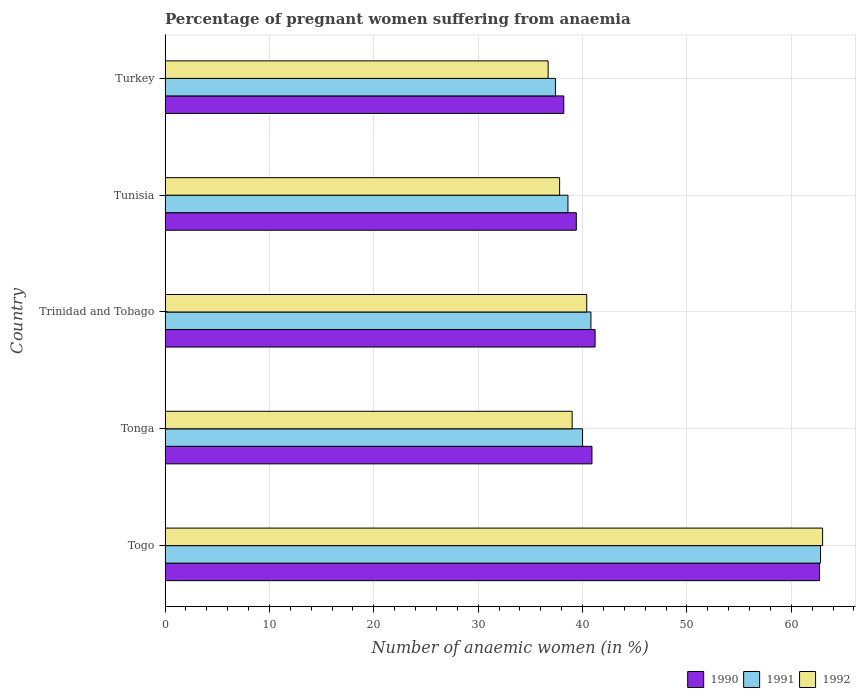How many different coloured bars are there?
Offer a very short reply. 3. Are the number of bars on each tick of the Y-axis equal?
Your answer should be very brief. Yes. What is the label of the 5th group of bars from the top?
Provide a short and direct response. Togo. What is the number of anaemic women in 1990 in Trinidad and Tobago?
Provide a succinct answer. 41.2. Across all countries, what is the maximum number of anaemic women in 1991?
Provide a succinct answer. 62.8. Across all countries, what is the minimum number of anaemic women in 1992?
Your answer should be very brief. 36.7. In which country was the number of anaemic women in 1991 maximum?
Keep it short and to the point. Togo. In which country was the number of anaemic women in 1991 minimum?
Ensure brevity in your answer.  Turkey. What is the total number of anaemic women in 1991 in the graph?
Keep it short and to the point. 219.6. What is the difference between the number of anaemic women in 1990 in Tunisia and that in Turkey?
Your answer should be very brief. 1.2. What is the difference between the number of anaemic women in 1990 in Tunisia and the number of anaemic women in 1991 in Trinidad and Tobago?
Make the answer very short. -1.4. What is the average number of anaemic women in 1991 per country?
Make the answer very short. 43.92. What is the difference between the number of anaemic women in 1990 and number of anaemic women in 1992 in Togo?
Keep it short and to the point. -0.3. In how many countries, is the number of anaemic women in 1992 greater than 62 %?
Keep it short and to the point. 1. What is the ratio of the number of anaemic women in 1991 in Tonga to that in Turkey?
Give a very brief answer. 1.07. What is the difference between the highest and the second highest number of anaemic women in 1992?
Your answer should be compact. 22.6. In how many countries, is the number of anaemic women in 1991 greater than the average number of anaemic women in 1991 taken over all countries?
Offer a very short reply. 1. Is the sum of the number of anaemic women in 1991 in Togo and Turkey greater than the maximum number of anaemic women in 1992 across all countries?
Offer a very short reply. Yes. What does the 1st bar from the top in Turkey represents?
Your response must be concise. 1992. What does the 2nd bar from the bottom in Tonga represents?
Offer a very short reply. 1991. How many bars are there?
Offer a very short reply. 15. What is the difference between two consecutive major ticks on the X-axis?
Give a very brief answer. 10. Are the values on the major ticks of X-axis written in scientific E-notation?
Your answer should be very brief. No. How many legend labels are there?
Your answer should be very brief. 3. How are the legend labels stacked?
Give a very brief answer. Horizontal. What is the title of the graph?
Your answer should be compact. Percentage of pregnant women suffering from anaemia. What is the label or title of the X-axis?
Your response must be concise. Number of anaemic women (in %). What is the Number of anaemic women (in %) of 1990 in Togo?
Offer a terse response. 62.7. What is the Number of anaemic women (in %) in 1991 in Togo?
Keep it short and to the point. 62.8. What is the Number of anaemic women (in %) in 1990 in Tonga?
Offer a terse response. 40.9. What is the Number of anaemic women (in %) of 1991 in Tonga?
Keep it short and to the point. 40. What is the Number of anaemic women (in %) in 1992 in Tonga?
Offer a terse response. 39. What is the Number of anaemic women (in %) of 1990 in Trinidad and Tobago?
Your response must be concise. 41.2. What is the Number of anaemic women (in %) in 1991 in Trinidad and Tobago?
Ensure brevity in your answer.  40.8. What is the Number of anaemic women (in %) of 1992 in Trinidad and Tobago?
Offer a terse response. 40.4. What is the Number of anaemic women (in %) in 1990 in Tunisia?
Give a very brief answer. 39.4. What is the Number of anaemic women (in %) of 1991 in Tunisia?
Give a very brief answer. 38.6. What is the Number of anaemic women (in %) in 1992 in Tunisia?
Make the answer very short. 37.8. What is the Number of anaemic women (in %) of 1990 in Turkey?
Your answer should be compact. 38.2. What is the Number of anaemic women (in %) of 1991 in Turkey?
Ensure brevity in your answer.  37.4. What is the Number of anaemic women (in %) in 1992 in Turkey?
Offer a very short reply. 36.7. Across all countries, what is the maximum Number of anaemic women (in %) of 1990?
Offer a terse response. 62.7. Across all countries, what is the maximum Number of anaemic women (in %) of 1991?
Provide a succinct answer. 62.8. Across all countries, what is the maximum Number of anaemic women (in %) of 1992?
Provide a short and direct response. 63. Across all countries, what is the minimum Number of anaemic women (in %) in 1990?
Your answer should be compact. 38.2. Across all countries, what is the minimum Number of anaemic women (in %) in 1991?
Provide a succinct answer. 37.4. Across all countries, what is the minimum Number of anaemic women (in %) of 1992?
Ensure brevity in your answer.  36.7. What is the total Number of anaemic women (in %) of 1990 in the graph?
Your response must be concise. 222.4. What is the total Number of anaemic women (in %) in 1991 in the graph?
Ensure brevity in your answer.  219.6. What is the total Number of anaemic women (in %) in 1992 in the graph?
Offer a very short reply. 216.9. What is the difference between the Number of anaemic women (in %) of 1990 in Togo and that in Tonga?
Your response must be concise. 21.8. What is the difference between the Number of anaemic women (in %) of 1991 in Togo and that in Tonga?
Offer a terse response. 22.8. What is the difference between the Number of anaemic women (in %) in 1990 in Togo and that in Trinidad and Tobago?
Your answer should be very brief. 21.5. What is the difference between the Number of anaemic women (in %) in 1991 in Togo and that in Trinidad and Tobago?
Offer a terse response. 22. What is the difference between the Number of anaemic women (in %) in 1992 in Togo and that in Trinidad and Tobago?
Provide a succinct answer. 22.6. What is the difference between the Number of anaemic women (in %) of 1990 in Togo and that in Tunisia?
Offer a very short reply. 23.3. What is the difference between the Number of anaemic women (in %) of 1991 in Togo and that in Tunisia?
Give a very brief answer. 24.2. What is the difference between the Number of anaemic women (in %) of 1992 in Togo and that in Tunisia?
Give a very brief answer. 25.2. What is the difference between the Number of anaemic women (in %) of 1990 in Togo and that in Turkey?
Provide a short and direct response. 24.5. What is the difference between the Number of anaemic women (in %) of 1991 in Togo and that in Turkey?
Make the answer very short. 25.4. What is the difference between the Number of anaemic women (in %) in 1992 in Togo and that in Turkey?
Keep it short and to the point. 26.3. What is the difference between the Number of anaemic women (in %) in 1991 in Tonga and that in Trinidad and Tobago?
Make the answer very short. -0.8. What is the difference between the Number of anaemic women (in %) of 1992 in Tonga and that in Trinidad and Tobago?
Provide a succinct answer. -1.4. What is the difference between the Number of anaemic women (in %) in 1992 in Tonga and that in Turkey?
Your answer should be very brief. 2.3. What is the difference between the Number of anaemic women (in %) in 1990 in Trinidad and Tobago and that in Tunisia?
Keep it short and to the point. 1.8. What is the difference between the Number of anaemic women (in %) in 1992 in Trinidad and Tobago and that in Tunisia?
Your response must be concise. 2.6. What is the difference between the Number of anaemic women (in %) of 1990 in Tunisia and that in Turkey?
Give a very brief answer. 1.2. What is the difference between the Number of anaemic women (in %) of 1990 in Togo and the Number of anaemic women (in %) of 1991 in Tonga?
Give a very brief answer. 22.7. What is the difference between the Number of anaemic women (in %) of 1990 in Togo and the Number of anaemic women (in %) of 1992 in Tonga?
Your answer should be very brief. 23.7. What is the difference between the Number of anaemic women (in %) in 1991 in Togo and the Number of anaemic women (in %) in 1992 in Tonga?
Your response must be concise. 23.8. What is the difference between the Number of anaemic women (in %) in 1990 in Togo and the Number of anaemic women (in %) in 1991 in Trinidad and Tobago?
Your response must be concise. 21.9. What is the difference between the Number of anaemic women (in %) of 1990 in Togo and the Number of anaemic women (in %) of 1992 in Trinidad and Tobago?
Give a very brief answer. 22.3. What is the difference between the Number of anaemic women (in %) of 1991 in Togo and the Number of anaemic women (in %) of 1992 in Trinidad and Tobago?
Offer a terse response. 22.4. What is the difference between the Number of anaemic women (in %) in 1990 in Togo and the Number of anaemic women (in %) in 1991 in Tunisia?
Provide a succinct answer. 24.1. What is the difference between the Number of anaemic women (in %) in 1990 in Togo and the Number of anaemic women (in %) in 1992 in Tunisia?
Ensure brevity in your answer.  24.9. What is the difference between the Number of anaemic women (in %) in 1991 in Togo and the Number of anaemic women (in %) in 1992 in Tunisia?
Offer a terse response. 25. What is the difference between the Number of anaemic women (in %) in 1990 in Togo and the Number of anaemic women (in %) in 1991 in Turkey?
Provide a succinct answer. 25.3. What is the difference between the Number of anaemic women (in %) of 1991 in Togo and the Number of anaemic women (in %) of 1992 in Turkey?
Ensure brevity in your answer.  26.1. What is the difference between the Number of anaemic women (in %) in 1990 in Tonga and the Number of anaemic women (in %) in 1992 in Trinidad and Tobago?
Your answer should be compact. 0.5. What is the difference between the Number of anaemic women (in %) of 1991 in Tonga and the Number of anaemic women (in %) of 1992 in Trinidad and Tobago?
Provide a succinct answer. -0.4. What is the difference between the Number of anaemic women (in %) of 1991 in Tonga and the Number of anaemic women (in %) of 1992 in Tunisia?
Provide a succinct answer. 2.2. What is the difference between the Number of anaemic women (in %) of 1990 in Trinidad and Tobago and the Number of anaemic women (in %) of 1991 in Tunisia?
Make the answer very short. 2.6. What is the difference between the Number of anaemic women (in %) of 1990 in Trinidad and Tobago and the Number of anaemic women (in %) of 1992 in Tunisia?
Make the answer very short. 3.4. What is the difference between the Number of anaemic women (in %) in 1991 in Trinidad and Tobago and the Number of anaemic women (in %) in 1992 in Tunisia?
Your response must be concise. 3. What is the difference between the Number of anaemic women (in %) of 1990 in Trinidad and Tobago and the Number of anaemic women (in %) of 1991 in Turkey?
Offer a terse response. 3.8. What is the difference between the Number of anaemic women (in %) in 1991 in Trinidad and Tobago and the Number of anaemic women (in %) in 1992 in Turkey?
Your response must be concise. 4.1. What is the difference between the Number of anaemic women (in %) in 1990 in Tunisia and the Number of anaemic women (in %) in 1991 in Turkey?
Offer a very short reply. 2. What is the average Number of anaemic women (in %) of 1990 per country?
Your response must be concise. 44.48. What is the average Number of anaemic women (in %) of 1991 per country?
Ensure brevity in your answer.  43.92. What is the average Number of anaemic women (in %) in 1992 per country?
Offer a terse response. 43.38. What is the difference between the Number of anaemic women (in %) of 1990 and Number of anaemic women (in %) of 1991 in Togo?
Provide a succinct answer. -0.1. What is the difference between the Number of anaemic women (in %) in 1990 and Number of anaemic women (in %) in 1992 in Tonga?
Offer a terse response. 1.9. What is the difference between the Number of anaemic women (in %) in 1990 and Number of anaemic women (in %) in 1991 in Trinidad and Tobago?
Keep it short and to the point. 0.4. What is the difference between the Number of anaemic women (in %) in 1990 and Number of anaemic women (in %) in 1992 in Trinidad and Tobago?
Your response must be concise. 0.8. What is the difference between the Number of anaemic women (in %) in 1991 and Number of anaemic women (in %) in 1992 in Trinidad and Tobago?
Offer a very short reply. 0.4. What is the difference between the Number of anaemic women (in %) of 1990 and Number of anaemic women (in %) of 1991 in Tunisia?
Provide a short and direct response. 0.8. What is the difference between the Number of anaemic women (in %) of 1990 and Number of anaemic women (in %) of 1992 in Tunisia?
Your answer should be very brief. 1.6. What is the difference between the Number of anaemic women (in %) in 1991 and Number of anaemic women (in %) in 1992 in Tunisia?
Your response must be concise. 0.8. What is the difference between the Number of anaemic women (in %) in 1990 and Number of anaemic women (in %) in 1991 in Turkey?
Your answer should be compact. 0.8. What is the ratio of the Number of anaemic women (in %) of 1990 in Togo to that in Tonga?
Your response must be concise. 1.53. What is the ratio of the Number of anaemic women (in %) in 1991 in Togo to that in Tonga?
Your answer should be compact. 1.57. What is the ratio of the Number of anaemic women (in %) in 1992 in Togo to that in Tonga?
Keep it short and to the point. 1.62. What is the ratio of the Number of anaemic women (in %) in 1990 in Togo to that in Trinidad and Tobago?
Provide a short and direct response. 1.52. What is the ratio of the Number of anaemic women (in %) in 1991 in Togo to that in Trinidad and Tobago?
Make the answer very short. 1.54. What is the ratio of the Number of anaemic women (in %) of 1992 in Togo to that in Trinidad and Tobago?
Offer a terse response. 1.56. What is the ratio of the Number of anaemic women (in %) in 1990 in Togo to that in Tunisia?
Give a very brief answer. 1.59. What is the ratio of the Number of anaemic women (in %) in 1991 in Togo to that in Tunisia?
Your response must be concise. 1.63. What is the ratio of the Number of anaemic women (in %) in 1992 in Togo to that in Tunisia?
Give a very brief answer. 1.67. What is the ratio of the Number of anaemic women (in %) of 1990 in Togo to that in Turkey?
Provide a short and direct response. 1.64. What is the ratio of the Number of anaemic women (in %) of 1991 in Togo to that in Turkey?
Offer a terse response. 1.68. What is the ratio of the Number of anaemic women (in %) in 1992 in Togo to that in Turkey?
Ensure brevity in your answer.  1.72. What is the ratio of the Number of anaemic women (in %) of 1990 in Tonga to that in Trinidad and Tobago?
Ensure brevity in your answer.  0.99. What is the ratio of the Number of anaemic women (in %) in 1991 in Tonga to that in Trinidad and Tobago?
Your response must be concise. 0.98. What is the ratio of the Number of anaemic women (in %) in 1992 in Tonga to that in Trinidad and Tobago?
Provide a succinct answer. 0.97. What is the ratio of the Number of anaemic women (in %) in 1990 in Tonga to that in Tunisia?
Your answer should be very brief. 1.04. What is the ratio of the Number of anaemic women (in %) in 1991 in Tonga to that in Tunisia?
Make the answer very short. 1.04. What is the ratio of the Number of anaemic women (in %) in 1992 in Tonga to that in Tunisia?
Offer a very short reply. 1.03. What is the ratio of the Number of anaemic women (in %) in 1990 in Tonga to that in Turkey?
Your answer should be very brief. 1.07. What is the ratio of the Number of anaemic women (in %) of 1991 in Tonga to that in Turkey?
Your answer should be very brief. 1.07. What is the ratio of the Number of anaemic women (in %) of 1992 in Tonga to that in Turkey?
Your response must be concise. 1.06. What is the ratio of the Number of anaemic women (in %) of 1990 in Trinidad and Tobago to that in Tunisia?
Give a very brief answer. 1.05. What is the ratio of the Number of anaemic women (in %) of 1991 in Trinidad and Tobago to that in Tunisia?
Your answer should be very brief. 1.06. What is the ratio of the Number of anaemic women (in %) in 1992 in Trinidad and Tobago to that in Tunisia?
Provide a succinct answer. 1.07. What is the ratio of the Number of anaemic women (in %) in 1990 in Trinidad and Tobago to that in Turkey?
Provide a short and direct response. 1.08. What is the ratio of the Number of anaemic women (in %) of 1992 in Trinidad and Tobago to that in Turkey?
Provide a succinct answer. 1.1. What is the ratio of the Number of anaemic women (in %) of 1990 in Tunisia to that in Turkey?
Your answer should be compact. 1.03. What is the ratio of the Number of anaemic women (in %) in 1991 in Tunisia to that in Turkey?
Provide a short and direct response. 1.03. What is the difference between the highest and the second highest Number of anaemic women (in %) in 1992?
Make the answer very short. 22.6. What is the difference between the highest and the lowest Number of anaemic women (in %) of 1991?
Your answer should be very brief. 25.4. What is the difference between the highest and the lowest Number of anaemic women (in %) in 1992?
Ensure brevity in your answer.  26.3. 